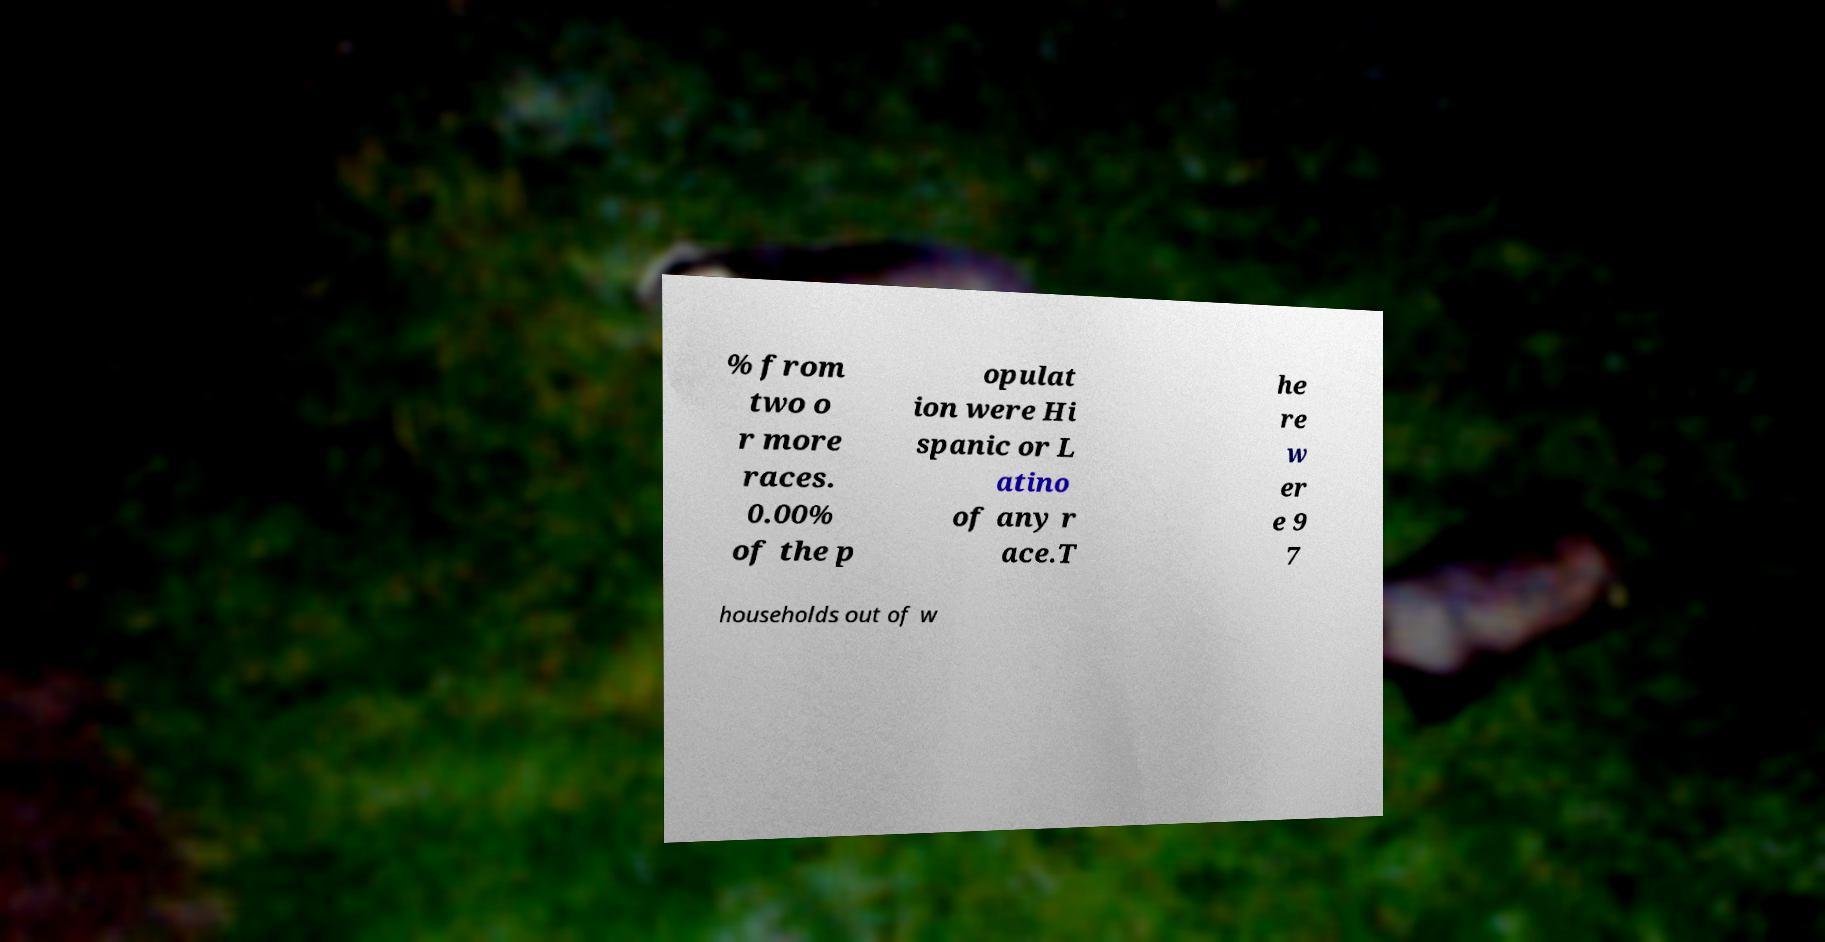Could you extract and type out the text from this image? % from two o r more races. 0.00% of the p opulat ion were Hi spanic or L atino of any r ace.T he re w er e 9 7 households out of w 